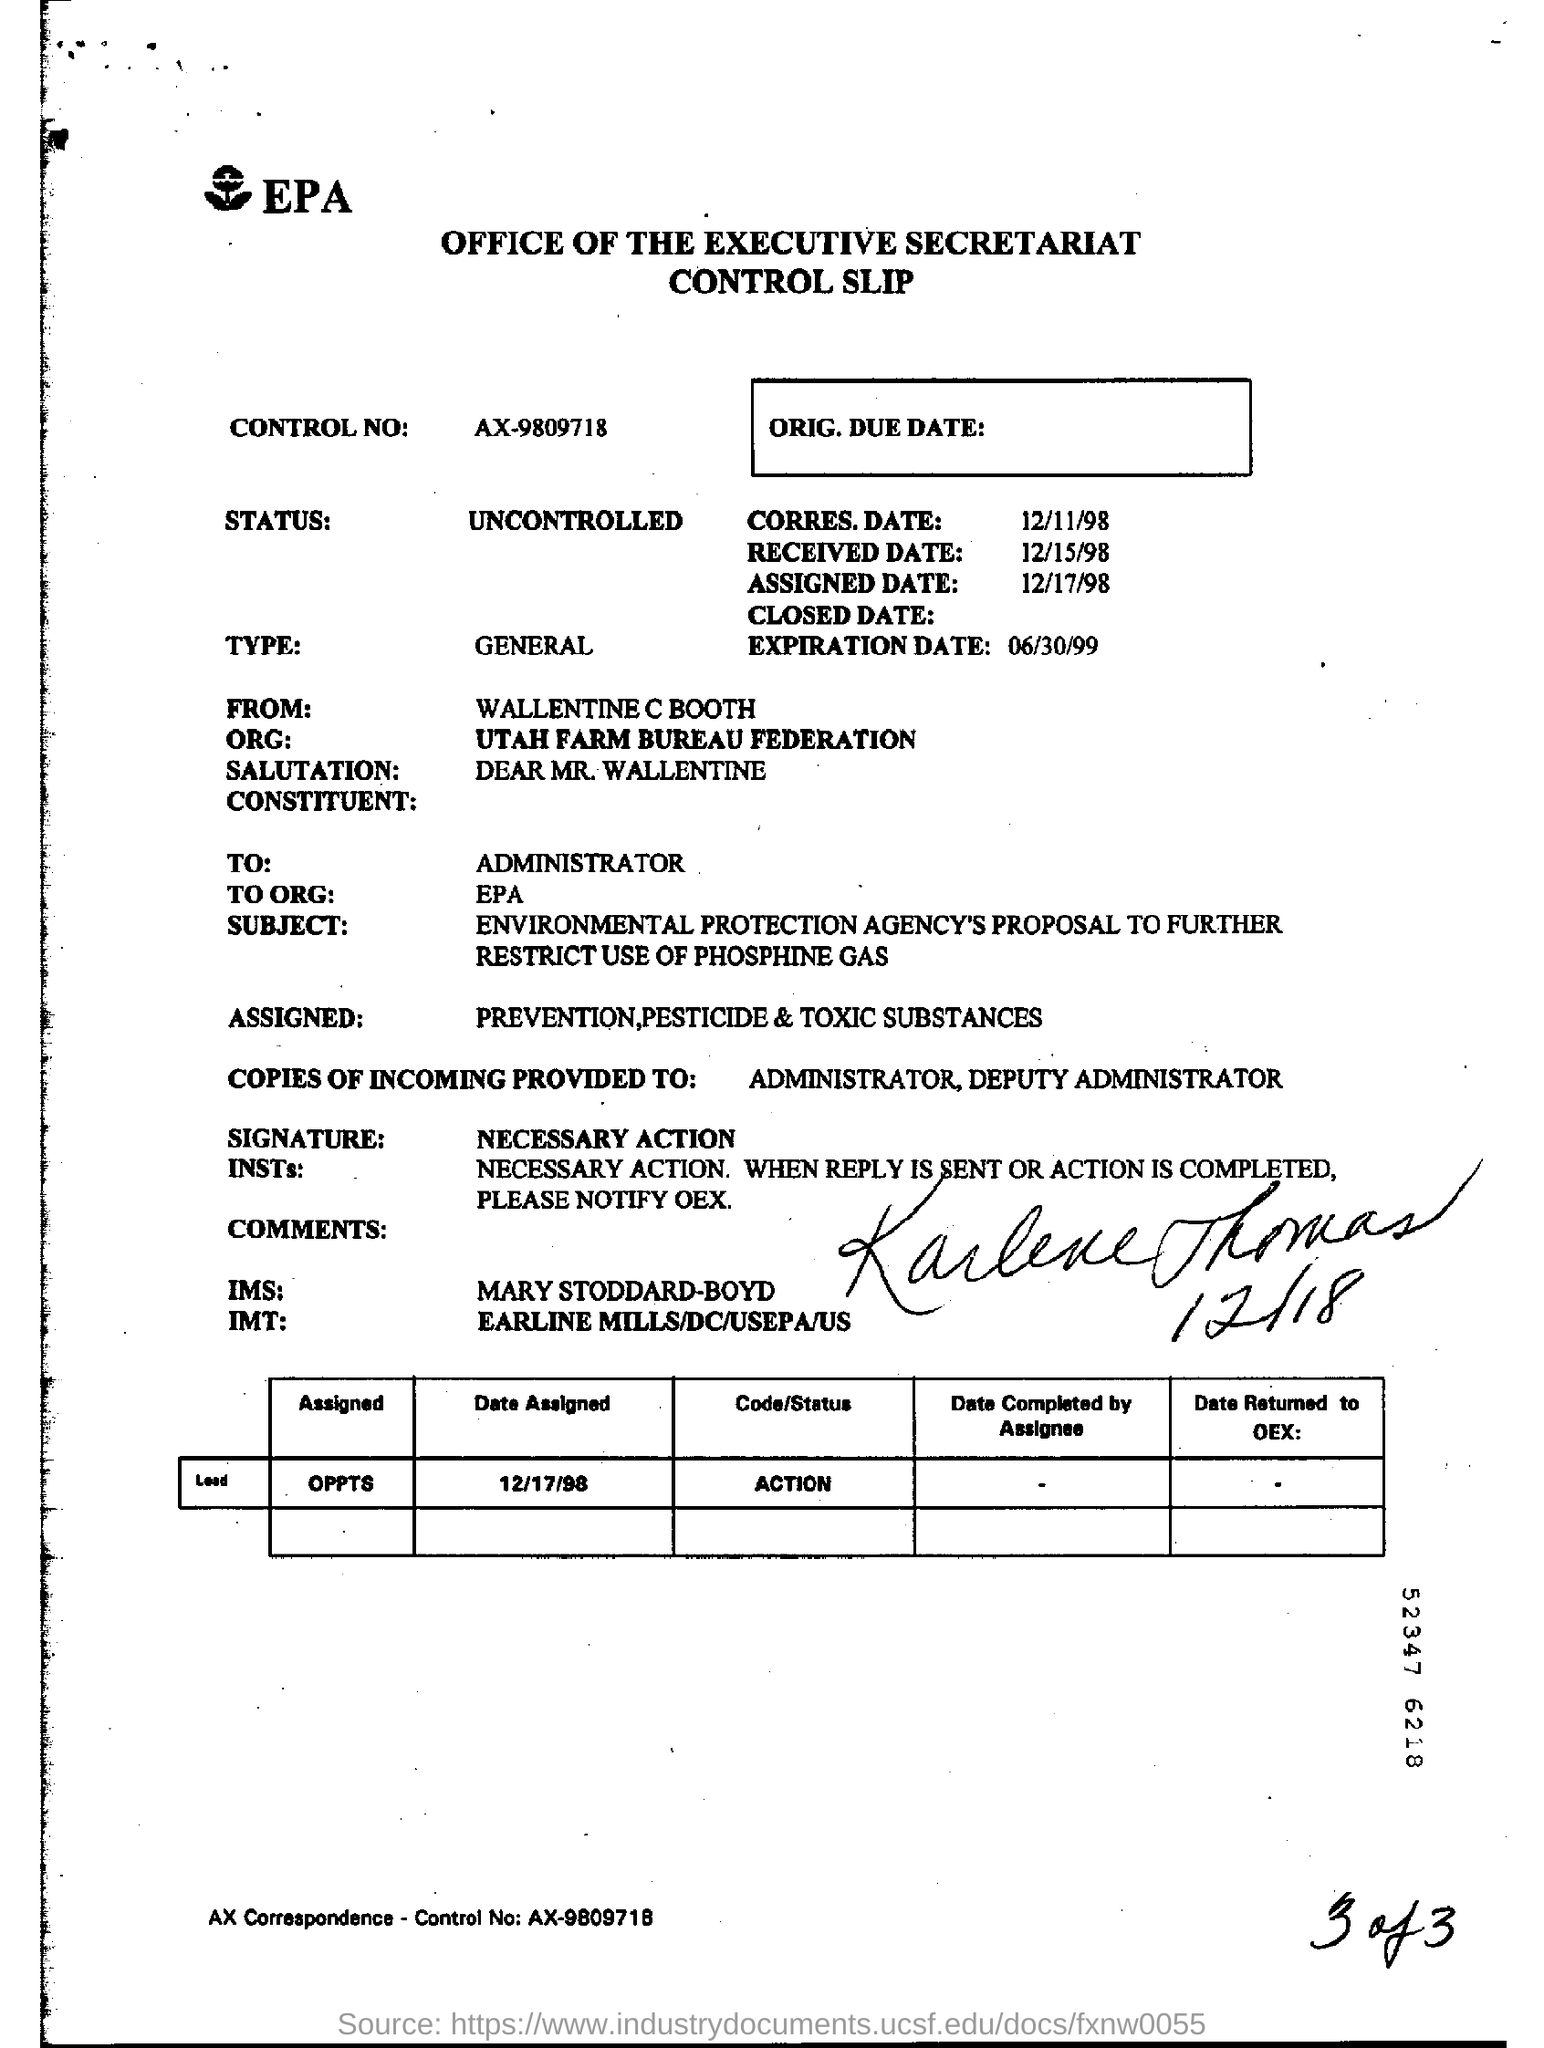What does the action status represent in this context? The action status 'ACTION' in the document denotes that the document has been actively assigned to a particular department or individual for further processing or response. It indicates that the subject, the EPA's proposal on phosphine gas, is currently under consideration or requires specific actions to be taken within the organizational processes of the EPA. 